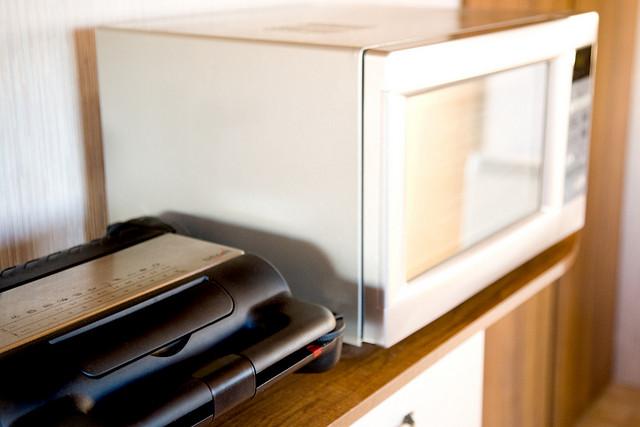What material is the shelf?
Answer briefly. Wood. Is the microwave on?
Keep it brief. No. What is the microwave sitting on?
Write a very short answer. Counter. 